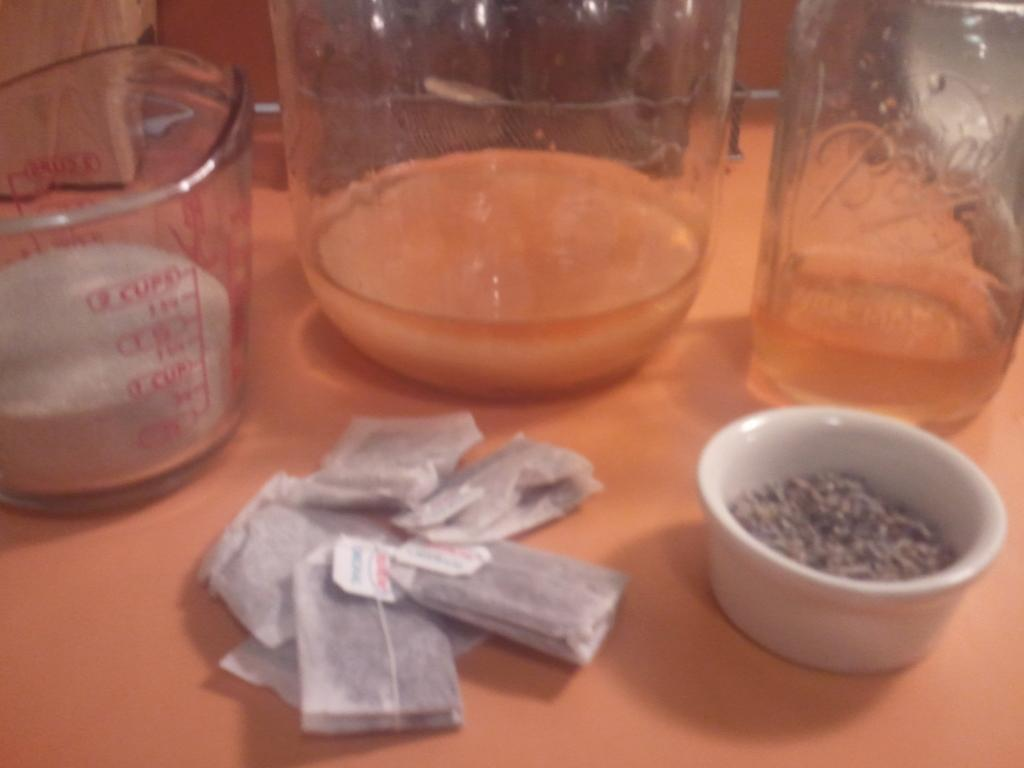<image>
Relay a brief, clear account of the picture shown. Several bags of what appears to be tea are on the table with a Ball jar and a 2 cup measuring cup. 